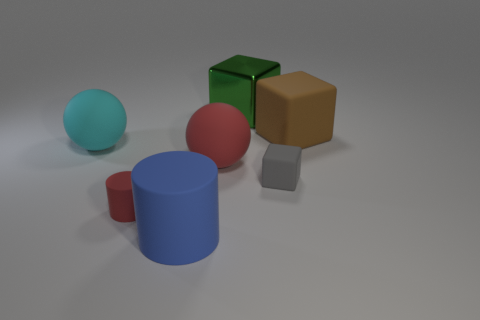How big is the red thing to the left of the matte cylinder on the right side of the red rubber object that is in front of the red rubber sphere?
Provide a succinct answer. Small. How many other things are there of the same size as the gray rubber cube?
Make the answer very short. 1. What number of big cyan things are the same material as the big green object?
Provide a succinct answer. 0. There is a big thing in front of the large red object; what is its shape?
Make the answer very short. Cylinder. Is the blue cylinder made of the same material as the big block right of the green metallic object?
Provide a short and direct response. Yes. Is there a small purple metallic thing?
Your answer should be compact. No. There is a object behind the large thing that is on the right side of the big metal object; are there any blocks right of it?
Provide a succinct answer. Yes. How many tiny objects are either gray matte cubes or matte cylinders?
Your response must be concise. 2. There is a cylinder that is the same size as the gray rubber thing; what color is it?
Your answer should be very brief. Red. There is a green metallic block; how many large brown matte blocks are left of it?
Offer a very short reply. 0. 